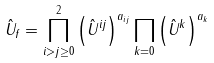<formula> <loc_0><loc_0><loc_500><loc_500>\hat { U } _ { f } = \prod _ { i > j \geq 0 } ^ { 2 } \left ( \hat { U } ^ { i j } \right ) ^ { a _ { i j } } \prod _ { k = 0 } \left ( \hat { U } ^ { k } \right ) ^ { a _ { k } }</formula> 